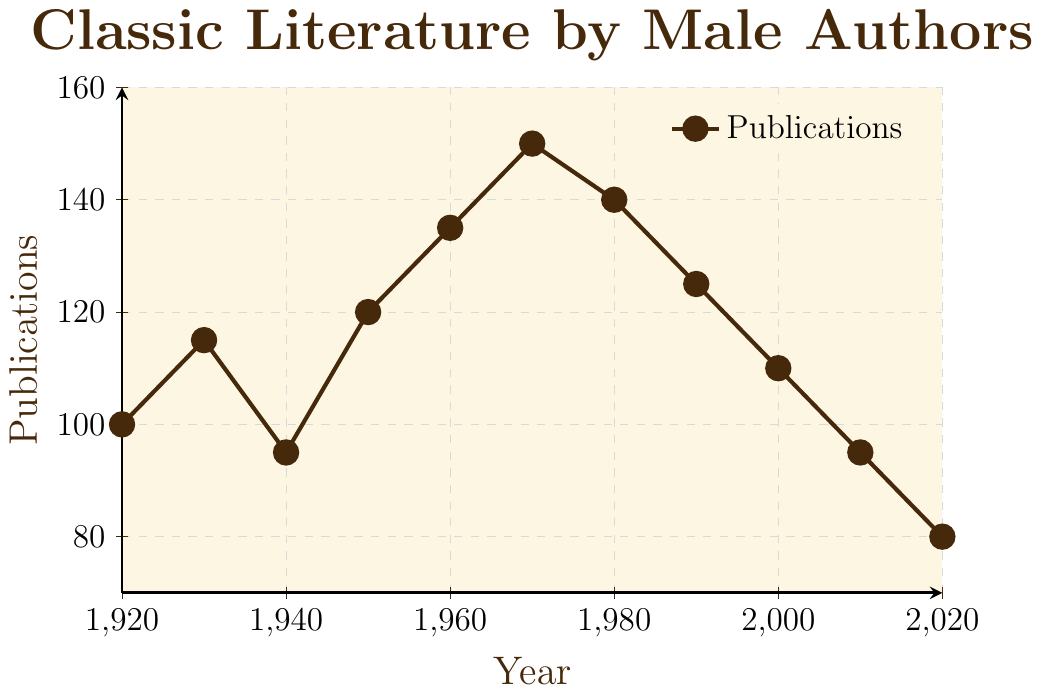What is the overall trend in the publications of classic literature by male authors from 1920 to 2020? By inspecting the general shape of the plotted line, we observe that it initially rises, reaching a peak around the 1970s, and then steadily declines through to 2020.
Answer: An initial increase, peaking in the 1970s, followed by a decline In which decade did the publications of classic literature by male authors peak? The peak can be found by identifying the highest point on the plot, which occurs around the year 1970.
Answer: 1970s Compare the number of publications in 1980 and 2020. By how much did the number of publications decrease? Looking at the y-values for 1980 and 2020, we see they are 140 and 80 respectively. The difference is 140 - 80.
Answer: 60 What is the average number of publications over the past century (1920 to 2020)? Sum the data points: 100 + 115 + 95 + 120 + 135 + 150 + 140 + 125 + 110 + 95 + 80 and divide by the number of years (11). The total sum is 1265; dividing by 11 gives 115.
Answer: 115 Identify the period when the number of publications was consistently decreasing. Observing the slope of the line from one point to another, the number of publications shows a continuous decline from 1970 to 2020.
Answer: 1970 to 2020 What is the difference between the highest and lowest number of publications in the dataset? The highest number of publications is 150 (in 1970), and the lowest is 80 (in 2020). Subtract the lowest from the highest: 150 - 80.
Answer: 70 During which decade(s) did the number of publications fall below 100? The y-values below 100 correspond to 1940, 2010, and 2020.
Answer: 1940, 2010, 2020 What is the rate of change in the number of publications from 1990 to 2000? The number of publications in 1990 is 125 and in 2000 is 110. The difference is 125 - 110. The rate of change is -15 per decade.
Answer: -15 per decade Visually, which two points are closest to each other in terms of the number of publications? By comparing the heights of the points on the y-axis, 1930 (115) and 2000 (110) appear to be the closest. The difference between them is 5.
Answer: 1930 and 2000 